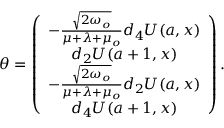<formula> <loc_0><loc_0><loc_500><loc_500>\theta = \left ( \begin{array} { c } { { - \frac { \sqrt { 2 \omega _ { o } } } { \mu + \lambda + \mu _ { o } } d _ { 4 } U ( a , x ) } } \\ { { d _ { 2 } U ( a + 1 , x ) } } \\ { { - \frac { \sqrt { 2 \omega _ { o } } } { \mu + \lambda + \mu _ { o } } d _ { 2 } U ( a , x ) } } \\ { { d _ { 4 } U ( a + 1 , x ) } } \end{array} \right ) .</formula> 